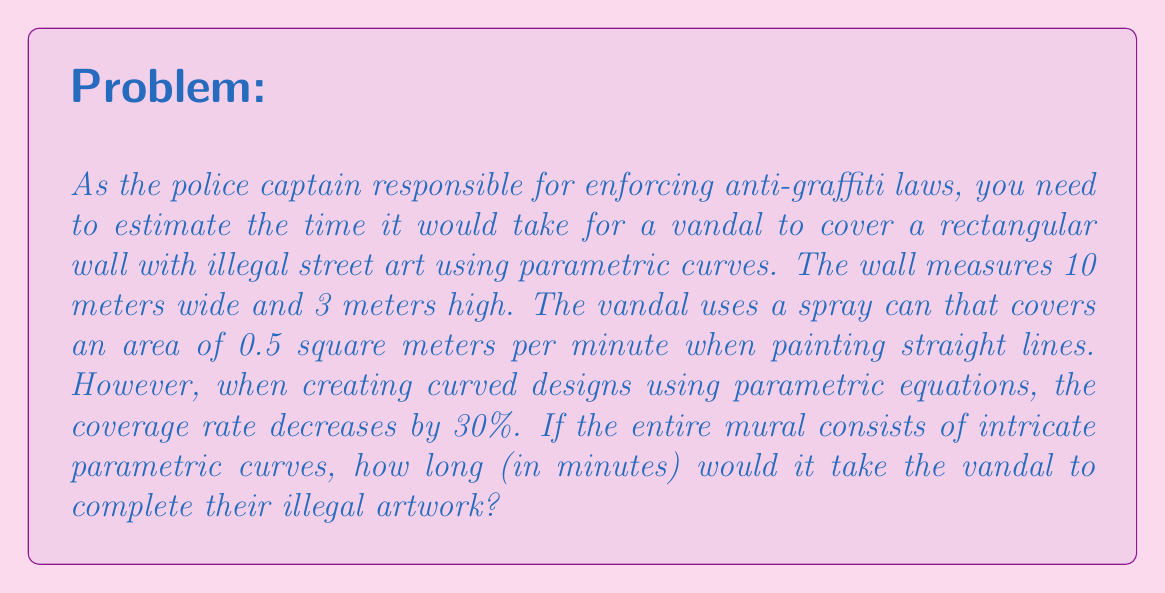Provide a solution to this math problem. To solve this problem, we'll follow these steps:

1. Calculate the total area of the wall:
   $$A = \text{width} \times \text{height} = 10 \text{ m} \times 3 \text{ m} = 30 \text{ m}^2$$

2. Determine the reduced coverage rate for parametric curves:
   Original rate: 0.5 m²/min
   Reduction: 30% = 0.3
   New rate: $0.5 \text{ m}^2/\text{min} \times (1 - 0.3) = 0.35 \text{ m}^2/\text{min}$

3. Calculate the time taken to cover the wall:
   $$\text{Time} = \frac{\text{Area}}{\text{Coverage Rate}}$$
   $$\text{Time} = \frac{30 \text{ m}^2}{0.35 \text{ m}^2/\text{min}}$$
   $$\text{Time} = 85.71 \text{ minutes}$$

4. Round up to the nearest minute, as we need to report the full time it would take:
   $$\text{Time} \approx 86 \text{ minutes}$$
Answer: 86 minutes 